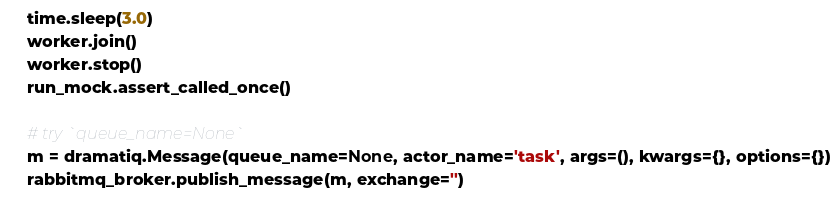<code> <loc_0><loc_0><loc_500><loc_500><_Python_>    time.sleep(3.0)
    worker.join()
    worker.stop()
    run_mock.assert_called_once()

    # try `queue_name=None`
    m = dramatiq.Message(queue_name=None, actor_name='task', args=(), kwargs={}, options={})
    rabbitmq_broker.publish_message(m, exchange='')
</code> 